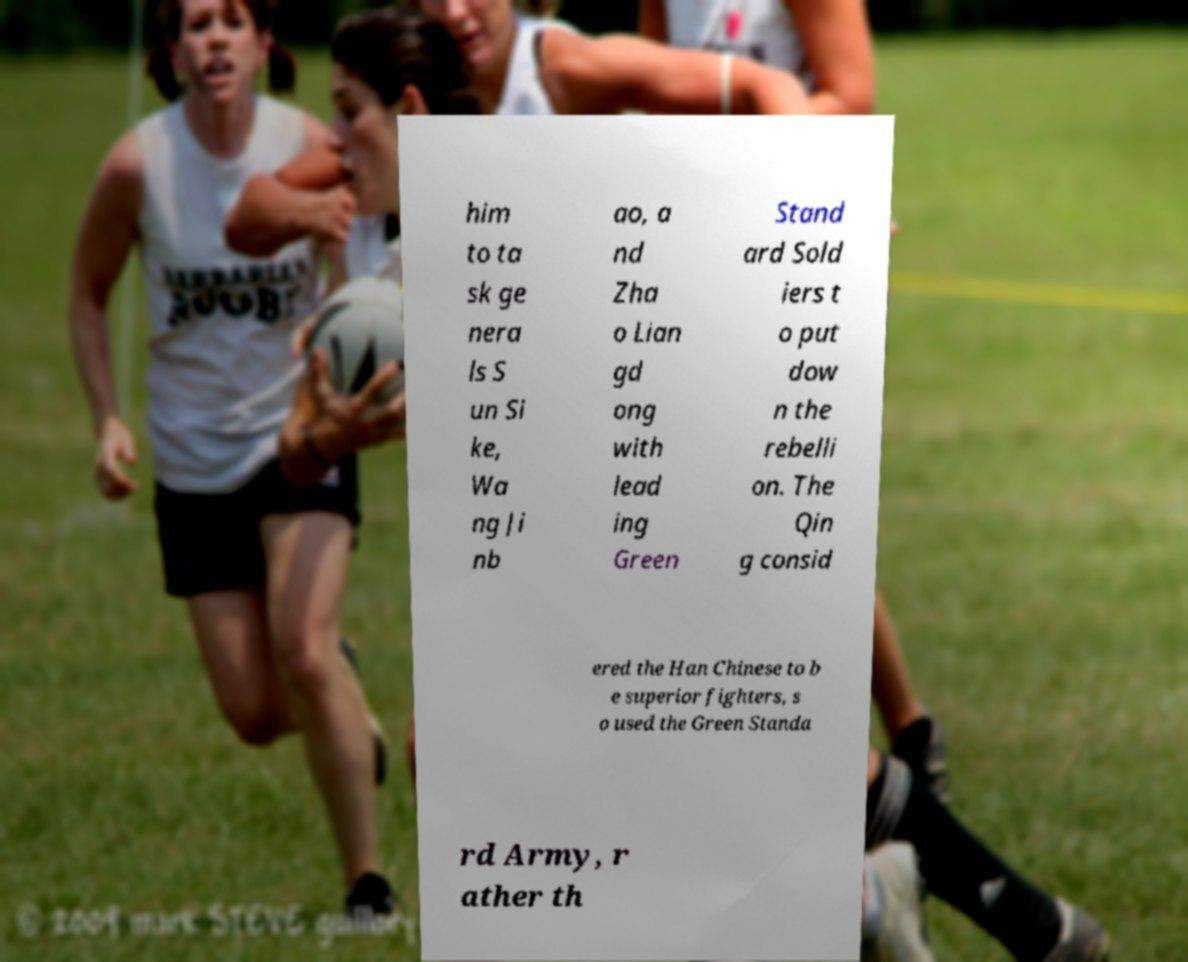Could you extract and type out the text from this image? him to ta sk ge nera ls S un Si ke, Wa ng Ji nb ao, a nd Zha o Lian gd ong with lead ing Green Stand ard Sold iers t o put dow n the rebelli on. The Qin g consid ered the Han Chinese to b e superior fighters, s o used the Green Standa rd Army, r ather th 